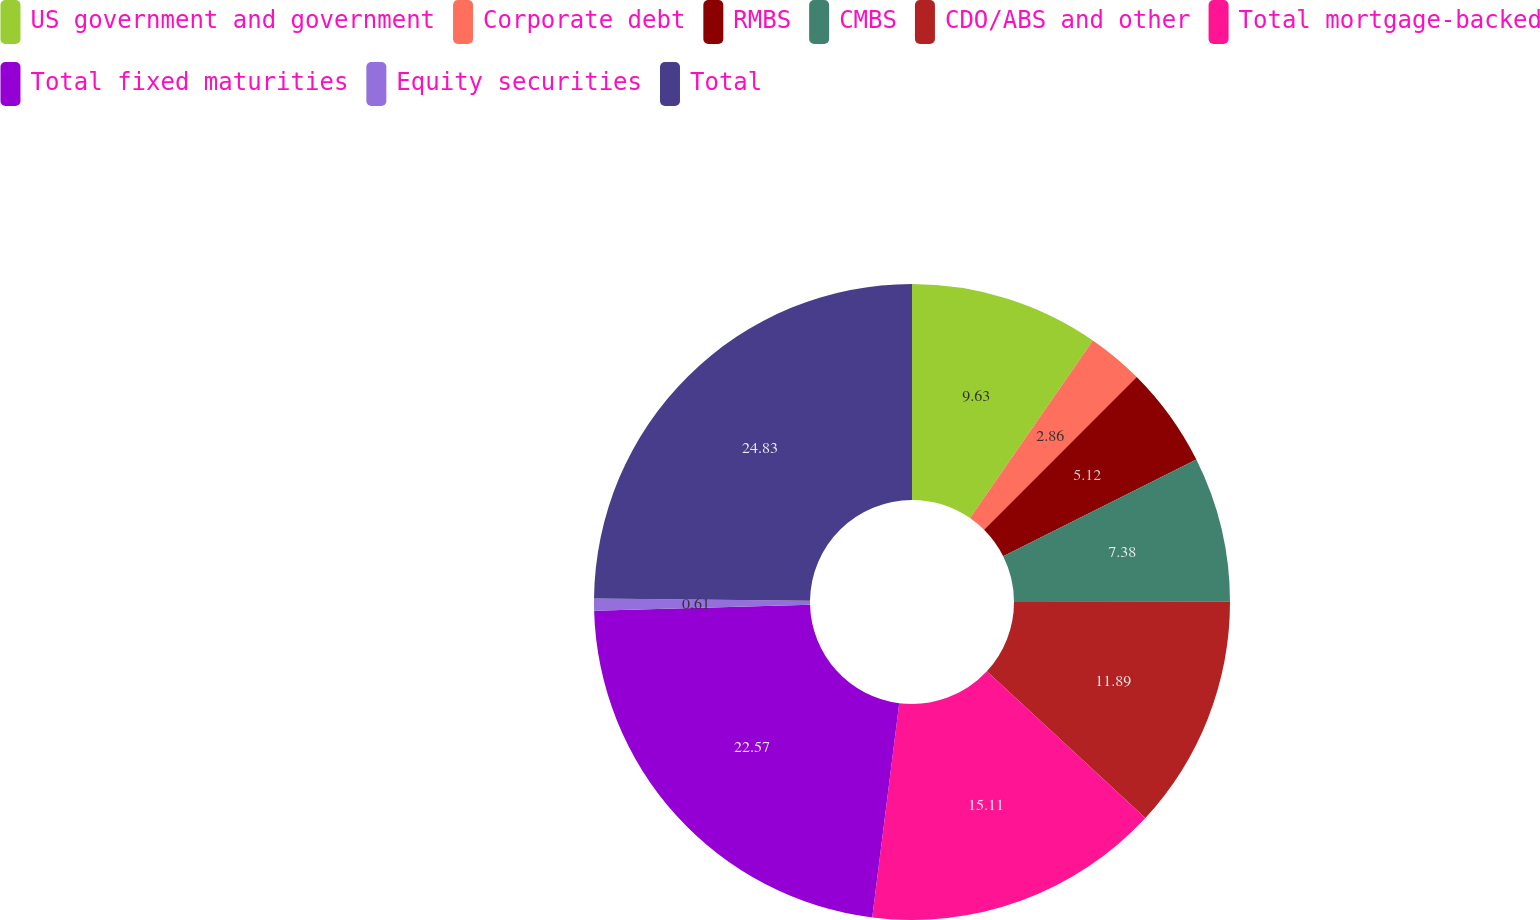Convert chart to OTSL. <chart><loc_0><loc_0><loc_500><loc_500><pie_chart><fcel>US government and government<fcel>Corporate debt<fcel>RMBS<fcel>CMBS<fcel>CDO/ABS and other<fcel>Total mortgage-backed<fcel>Total fixed maturities<fcel>Equity securities<fcel>Total<nl><fcel>9.63%<fcel>2.86%<fcel>5.12%<fcel>7.38%<fcel>11.89%<fcel>15.11%<fcel>22.57%<fcel>0.61%<fcel>24.82%<nl></chart> 